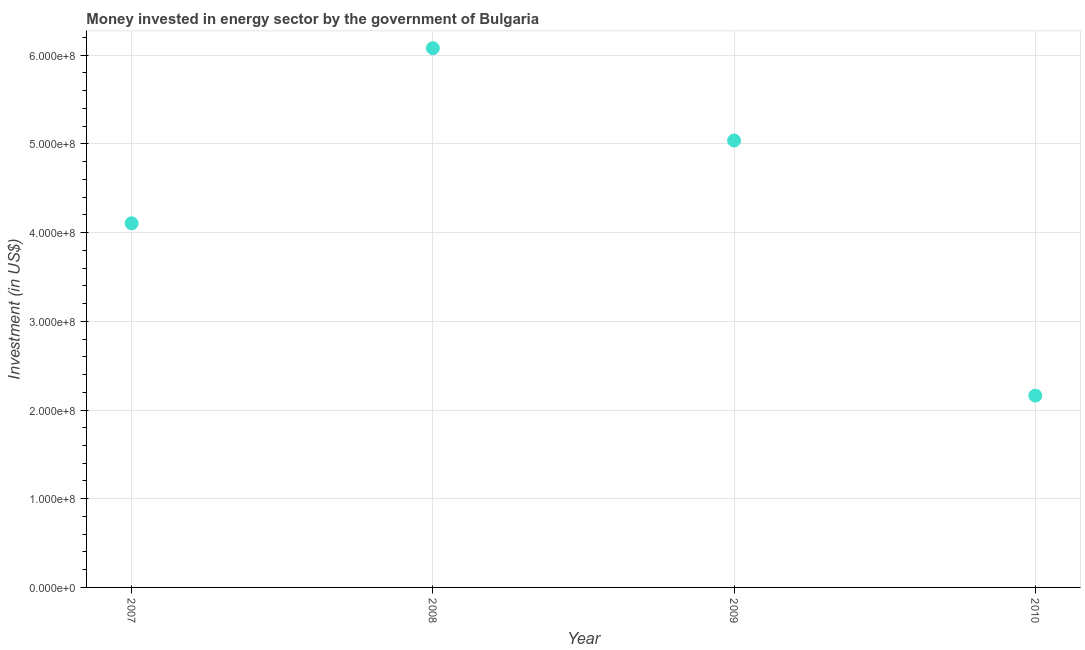What is the investment in energy in 2008?
Your response must be concise. 6.08e+08. Across all years, what is the maximum investment in energy?
Provide a succinct answer. 6.08e+08. Across all years, what is the minimum investment in energy?
Make the answer very short. 2.16e+08. In which year was the investment in energy maximum?
Offer a very short reply. 2008. What is the sum of the investment in energy?
Offer a very short reply. 1.74e+09. What is the difference between the investment in energy in 2009 and 2010?
Your response must be concise. 2.88e+08. What is the average investment in energy per year?
Ensure brevity in your answer.  4.35e+08. What is the median investment in energy?
Offer a very short reply. 4.57e+08. In how many years, is the investment in energy greater than 380000000 US$?
Ensure brevity in your answer.  3. Do a majority of the years between 2007 and 2010 (inclusive) have investment in energy greater than 380000000 US$?
Your answer should be compact. Yes. What is the ratio of the investment in energy in 2008 to that in 2009?
Offer a very short reply. 1.21. Is the difference between the investment in energy in 2007 and 2010 greater than the difference between any two years?
Ensure brevity in your answer.  No. What is the difference between the highest and the second highest investment in energy?
Your response must be concise. 1.04e+08. What is the difference between the highest and the lowest investment in energy?
Offer a very short reply. 3.92e+08. How many dotlines are there?
Offer a very short reply. 1. What is the difference between two consecutive major ticks on the Y-axis?
Your response must be concise. 1.00e+08. Does the graph contain any zero values?
Make the answer very short. No. Does the graph contain grids?
Your response must be concise. Yes. What is the title of the graph?
Your response must be concise. Money invested in energy sector by the government of Bulgaria. What is the label or title of the Y-axis?
Provide a short and direct response. Investment (in US$). What is the Investment (in US$) in 2007?
Your answer should be compact. 4.10e+08. What is the Investment (in US$) in 2008?
Provide a short and direct response. 6.08e+08. What is the Investment (in US$) in 2009?
Make the answer very short. 5.04e+08. What is the Investment (in US$) in 2010?
Give a very brief answer. 2.16e+08. What is the difference between the Investment (in US$) in 2007 and 2008?
Your answer should be very brief. -1.97e+08. What is the difference between the Investment (in US$) in 2007 and 2009?
Offer a very short reply. -9.33e+07. What is the difference between the Investment (in US$) in 2007 and 2010?
Offer a terse response. 1.94e+08. What is the difference between the Investment (in US$) in 2008 and 2009?
Offer a terse response. 1.04e+08. What is the difference between the Investment (in US$) in 2008 and 2010?
Provide a short and direct response. 3.92e+08. What is the difference between the Investment (in US$) in 2009 and 2010?
Keep it short and to the point. 2.88e+08. What is the ratio of the Investment (in US$) in 2007 to that in 2008?
Offer a terse response. 0.68. What is the ratio of the Investment (in US$) in 2007 to that in 2009?
Offer a terse response. 0.81. What is the ratio of the Investment (in US$) in 2007 to that in 2010?
Make the answer very short. 1.9. What is the ratio of the Investment (in US$) in 2008 to that in 2009?
Your response must be concise. 1.21. What is the ratio of the Investment (in US$) in 2008 to that in 2010?
Ensure brevity in your answer.  2.81. What is the ratio of the Investment (in US$) in 2009 to that in 2010?
Offer a terse response. 2.33. 